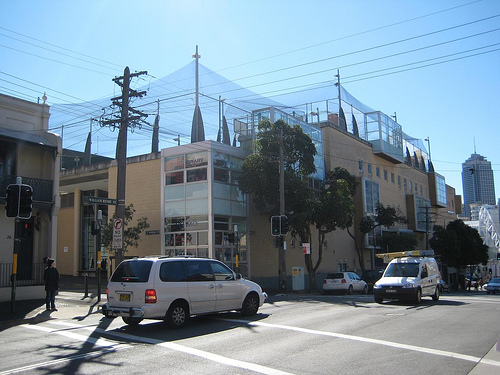<image>
Is the car on the road? Yes. Looking at the image, I can see the car is positioned on top of the road, with the road providing support. 